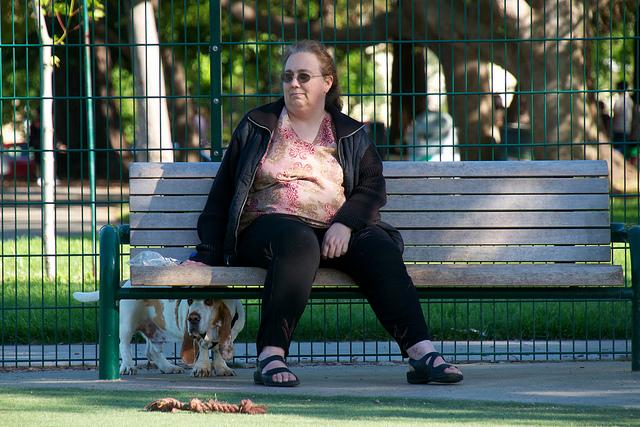What dog breed does the woman have? Please explain your reasoning. bassett hound. A short dog with long ears stands near a woman in a bench. basset hounds are short and have long ears. 